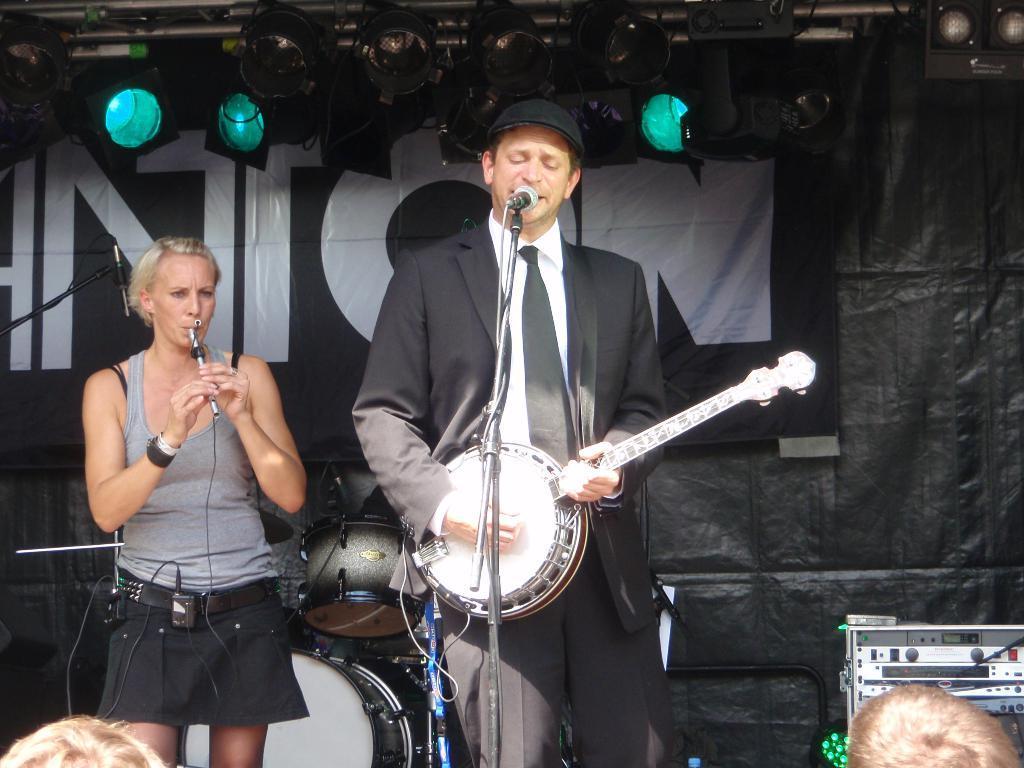Please provide a concise description of this image. There are 2 persons on the stage playing musical instruments. This is a microphone. Behind them there are lights and musical instruments. 